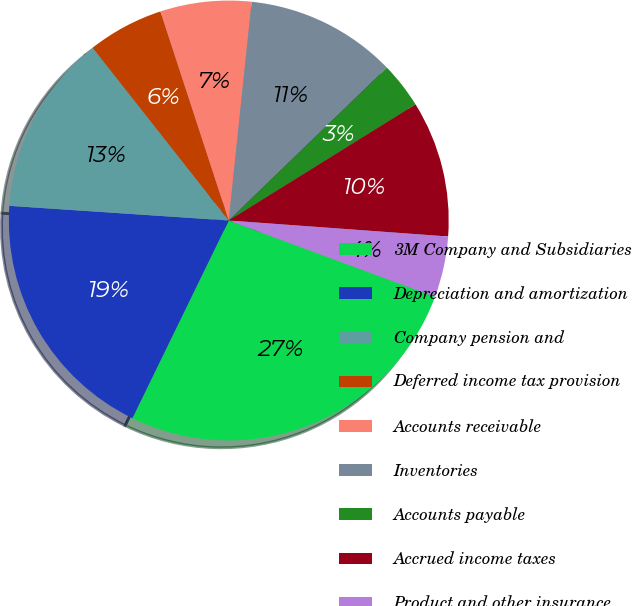Convert chart. <chart><loc_0><loc_0><loc_500><loc_500><pie_chart><fcel>3M Company and Subsidiaries<fcel>Depreciation and amortization<fcel>Company pension and<fcel>Deferred income tax provision<fcel>Accounts receivable<fcel>Inventories<fcel>Accounts payable<fcel>Accrued income taxes<fcel>Product and other insurance<nl><fcel>26.58%<fcel>18.85%<fcel>13.32%<fcel>5.59%<fcel>6.69%<fcel>11.11%<fcel>3.38%<fcel>10.01%<fcel>4.48%<nl></chart> 